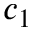Convert formula to latex. <formula><loc_0><loc_0><loc_500><loc_500>c _ { 1 }</formula> 